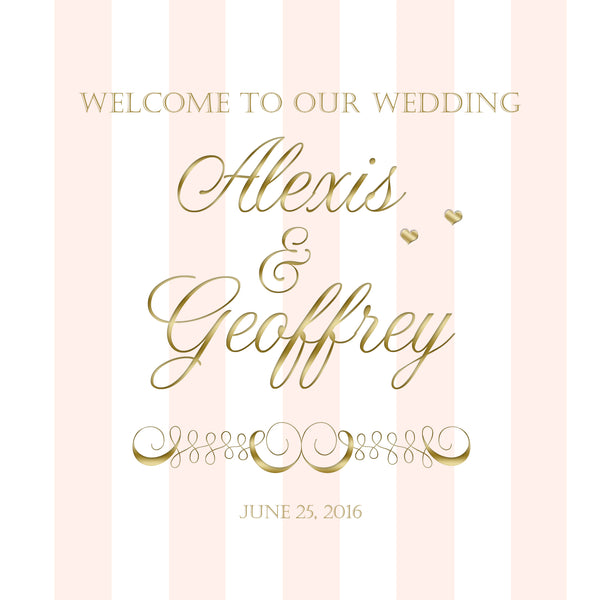The invitation is elegant and features soft colors. What kind of attire might the wedding party wear? For a wedding with such an elegant and soft color scheme, the wedding party might wear formal attire. Bridesmaids could wear long, blush pink dresses, matching the invitation's background, while the groomsmen might don classic black or navy suits with gold or pink accents such as ties or pocket squares. The bride might choose a gown with intricate lace details and the groom a sophisticated tuxedo, possibly with a gold bow tie. 